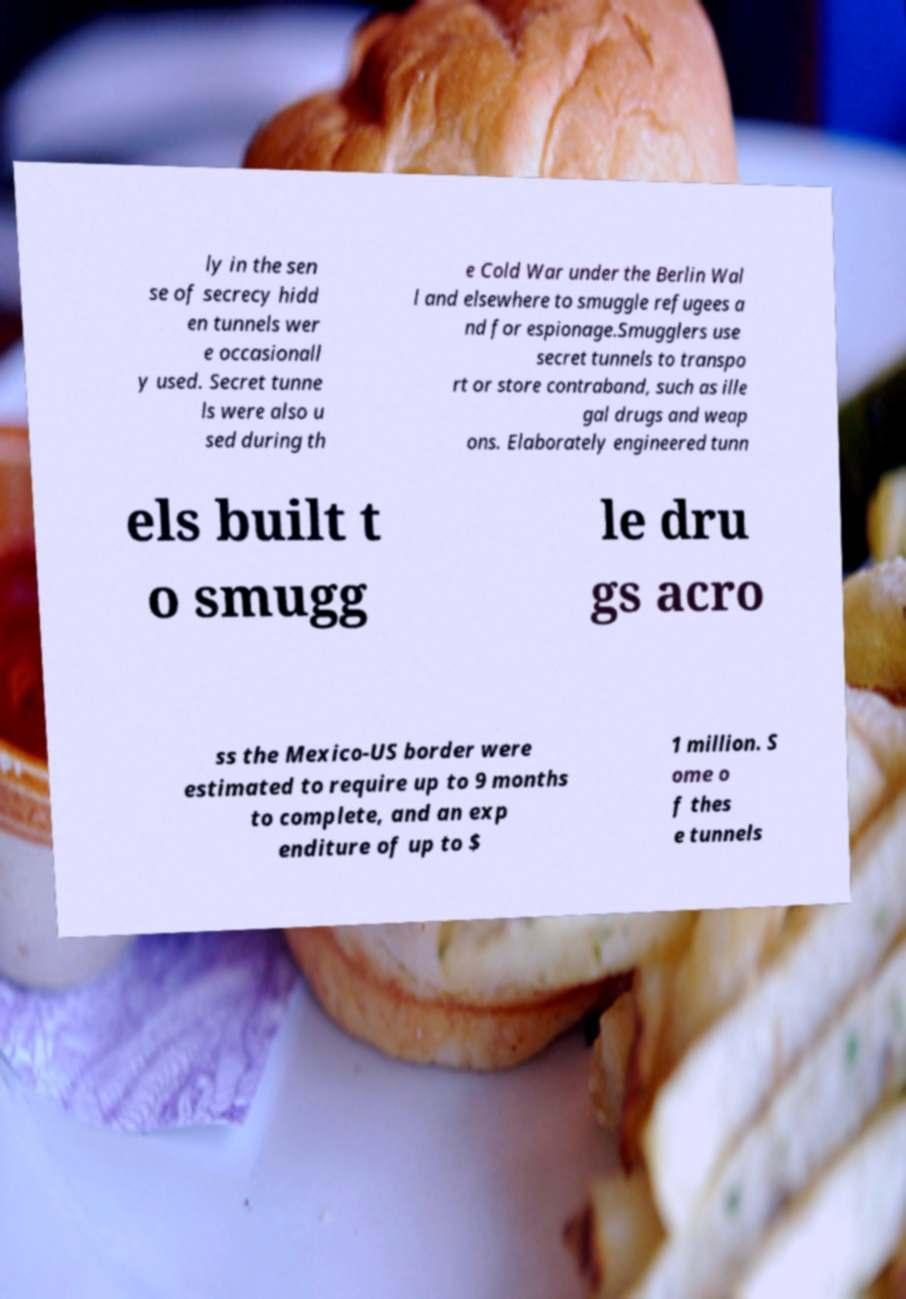Please identify and transcribe the text found in this image. ly in the sen se of secrecy hidd en tunnels wer e occasionall y used. Secret tunne ls were also u sed during th e Cold War under the Berlin Wal l and elsewhere to smuggle refugees a nd for espionage.Smugglers use secret tunnels to transpo rt or store contraband, such as ille gal drugs and weap ons. Elaborately engineered tunn els built t o smugg le dru gs acro ss the Mexico-US border were estimated to require up to 9 months to complete, and an exp enditure of up to $ 1 million. S ome o f thes e tunnels 